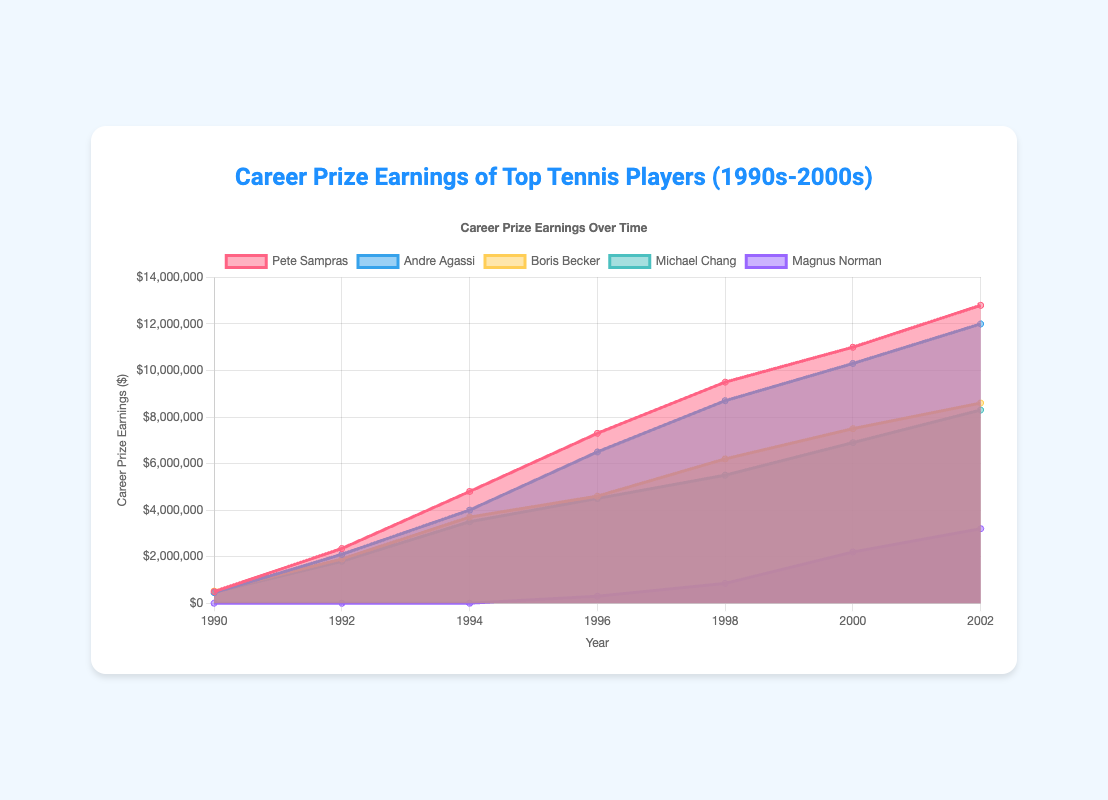What is the total career prize earnings of Pete Sampras in the year 2002? To find Pete Sampras's career prize earnings for the year 2002, we look at the corresponding data point for Pete Sampras in the 'data' section and see that it is listed as $12,800,000.
Answer: $12,800,000 How does Andre Agassi's career prize earnings in 1996 compare to that of 1998? To compare Andre Agassi's career prize earnings between 1996 and 1998, we check the data points for both years. In 1996, he earned $6,500,000, and in 1998, he earned $8,700,000. Therefore, earnings increased from 1996 to 1998.
Answer: Increased What is the difference in career prize earnings between Boris Becker and Michael Chang in 2002? First, identify Boris Becker's earnings in 2002, which is $8,600,000, and Michael Chang's earnings in the same year, which is $8,300,000. Then, calculate the difference: $8,600,000 - $8,300,000 = $300,000.
Answer: $300,000 Which player has the smallest career prize earnings in 1992 and what is the value? By reviewing the data for 1992, we see the earnings for Pete Sampras ($2,350,000), Andre Agassi ($2,100,000), Boris Becker ($1,900,000), and Michael Chang ($1,800,000). Magnus Norman has no earnings listed for that year. Therefore, Michael Chang has the smallest prize earnings with $1,800,000.
Answer: Michael Chang, $1,800,000 Between which years did Pete Sampras see the biggest increase in his career prize earnings? To determine the biggest increase, we calculate the differences between the successive years for Pete Sampras. The differences are 1992-1990: $1,850,000, 1994-1992: $2,450,000, 1996-1994: $2,500,000, 1998-1996: $2,200,000, 2000-1998: $1,500,000, and 2002-2000: $1,800,000. The largest increase is from 1994 to 1996 with a $2,500,000 increase.
Answer: 1994 to 1996 What is the average career prize earnings of Michael Chang from 1990 to 2002? Sum up Michael Chang's earnings from each year: $470,000 (1990) + $1,800,000 (1992) + $3,500,000 (1994) + $4,500,000 (1996) + $5,500,000 (1998) + $6,900,000 (2000) + $8,300,000 (2002) = $30,970,000. Then divide by the number of data points (7): $30,970,000 / 7 = approximately $4,424,286.
Answer: $4,424,286 Which player had the highest prize earnings in 2000? To determine this, compare the 2000 earnings of all players listed: Pete Sampras ($11,000,000), Andre Agassi ($10,300,000), Boris Becker ($7,500,000), Michael Chang ($6,900,000), and Magnus Norman ($2,200,000). Pete Sampras had the highest earnings with $11,000,000.
Answer: Pete Sampras For which years is the prize earnings data of Magnus Norman available? Reviewing the data for Magnus Norman shows that his earnings start in 1996 and are listed for the following years: 1996, 1998, 2000, and 2002. His earnings are $300,000 (1996), $850,000 (1998), $2,200,000 (2000), and $3,200,000 (2002).
Answer: 1996, 1998, 2000, 2002 